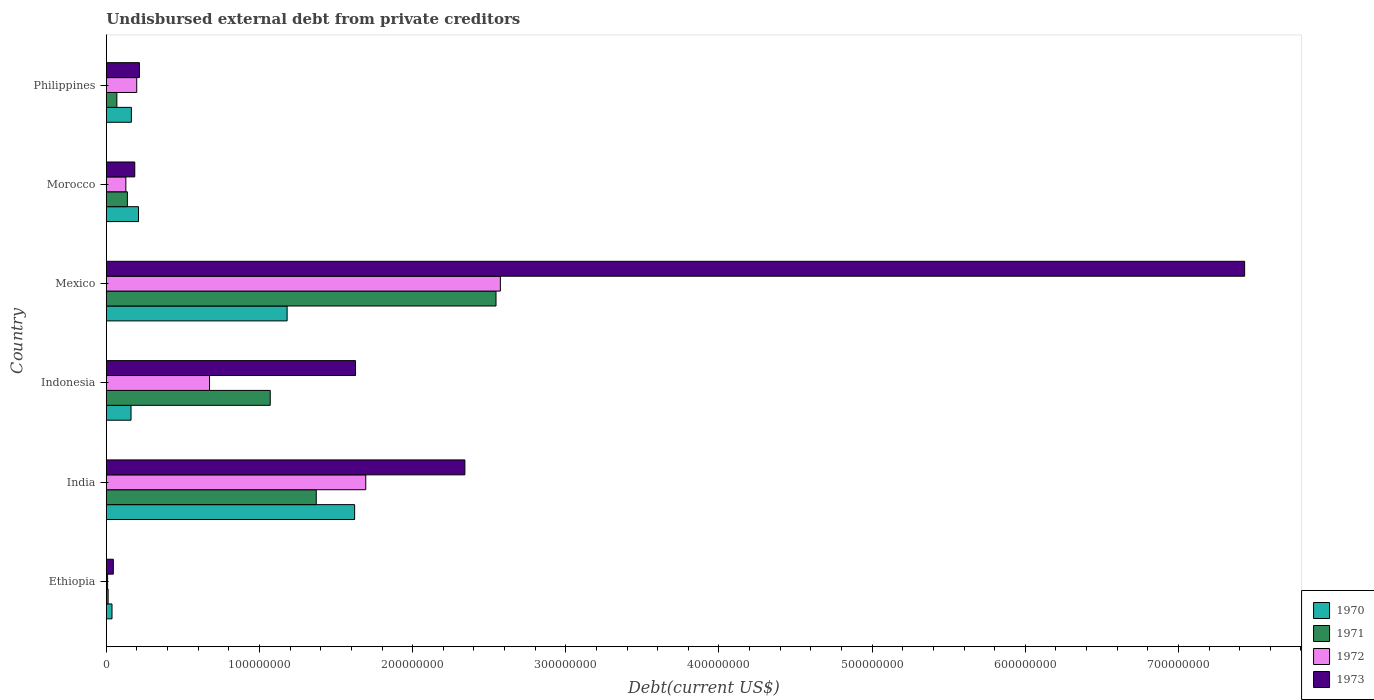How many groups of bars are there?
Your answer should be very brief. 6. Are the number of bars on each tick of the Y-axis equal?
Keep it short and to the point. Yes. How many bars are there on the 2nd tick from the top?
Your answer should be compact. 4. What is the label of the 3rd group of bars from the top?
Your response must be concise. Mexico. In how many cases, is the number of bars for a given country not equal to the number of legend labels?
Ensure brevity in your answer.  0. What is the total debt in 1972 in Morocco?
Your answer should be very brief. 1.27e+07. Across all countries, what is the maximum total debt in 1972?
Provide a short and direct response. 2.57e+08. Across all countries, what is the minimum total debt in 1970?
Give a very brief answer. 3.70e+06. In which country was the total debt in 1971 maximum?
Provide a succinct answer. Mexico. In which country was the total debt in 1971 minimum?
Keep it short and to the point. Ethiopia. What is the total total debt in 1972 in the graph?
Keep it short and to the point. 5.27e+08. What is the difference between the total debt in 1972 in Indonesia and that in Morocco?
Offer a very short reply. 5.46e+07. What is the difference between the total debt in 1970 in Morocco and the total debt in 1973 in Philippines?
Your answer should be very brief. -6.03e+05. What is the average total debt in 1970 per country?
Make the answer very short. 5.62e+07. What is the difference between the total debt in 1971 and total debt in 1972 in Philippines?
Make the answer very short. -1.30e+07. What is the ratio of the total debt in 1970 in Ethiopia to that in Philippines?
Ensure brevity in your answer.  0.23. Is the total debt in 1973 in India less than that in Morocco?
Provide a succinct answer. No. What is the difference between the highest and the second highest total debt in 1973?
Your response must be concise. 5.09e+08. What is the difference between the highest and the lowest total debt in 1971?
Give a very brief answer. 2.53e+08. Is the sum of the total debt in 1973 in Ethiopia and Morocco greater than the maximum total debt in 1971 across all countries?
Your answer should be compact. No. What does the 1st bar from the bottom in Morocco represents?
Offer a very short reply. 1970. What is the difference between two consecutive major ticks on the X-axis?
Provide a succinct answer. 1.00e+08. Are the values on the major ticks of X-axis written in scientific E-notation?
Offer a very short reply. No. Does the graph contain any zero values?
Offer a terse response. No. Does the graph contain grids?
Your answer should be compact. No. Where does the legend appear in the graph?
Offer a very short reply. Bottom right. How are the legend labels stacked?
Your response must be concise. Vertical. What is the title of the graph?
Your response must be concise. Undisbursed external debt from private creditors. Does "1982" appear as one of the legend labels in the graph?
Keep it short and to the point. No. What is the label or title of the X-axis?
Your answer should be compact. Debt(current US$). What is the label or title of the Y-axis?
Your answer should be compact. Country. What is the Debt(current US$) in 1970 in Ethiopia?
Your answer should be compact. 3.70e+06. What is the Debt(current US$) of 1971 in Ethiopia?
Ensure brevity in your answer.  1.16e+06. What is the Debt(current US$) of 1972 in Ethiopia?
Offer a very short reply. 8.20e+05. What is the Debt(current US$) in 1973 in Ethiopia?
Ensure brevity in your answer.  4.57e+06. What is the Debt(current US$) of 1970 in India?
Offer a very short reply. 1.62e+08. What is the Debt(current US$) of 1971 in India?
Offer a very short reply. 1.37e+08. What is the Debt(current US$) of 1972 in India?
Provide a succinct answer. 1.69e+08. What is the Debt(current US$) of 1973 in India?
Provide a succinct answer. 2.34e+08. What is the Debt(current US$) in 1970 in Indonesia?
Ensure brevity in your answer.  1.61e+07. What is the Debt(current US$) of 1971 in Indonesia?
Provide a succinct answer. 1.07e+08. What is the Debt(current US$) in 1972 in Indonesia?
Your answer should be very brief. 6.74e+07. What is the Debt(current US$) in 1973 in Indonesia?
Keep it short and to the point. 1.63e+08. What is the Debt(current US$) in 1970 in Mexico?
Your response must be concise. 1.18e+08. What is the Debt(current US$) of 1971 in Mexico?
Give a very brief answer. 2.54e+08. What is the Debt(current US$) in 1972 in Mexico?
Provide a succinct answer. 2.57e+08. What is the Debt(current US$) in 1973 in Mexico?
Provide a succinct answer. 7.43e+08. What is the Debt(current US$) in 1970 in Morocco?
Provide a short and direct response. 2.10e+07. What is the Debt(current US$) of 1971 in Morocco?
Your answer should be compact. 1.37e+07. What is the Debt(current US$) of 1972 in Morocco?
Offer a very short reply. 1.27e+07. What is the Debt(current US$) in 1973 in Morocco?
Make the answer very short. 1.86e+07. What is the Debt(current US$) of 1970 in Philippines?
Provide a succinct answer. 1.64e+07. What is the Debt(current US$) in 1971 in Philippines?
Keep it short and to the point. 6.87e+06. What is the Debt(current US$) of 1972 in Philippines?
Your answer should be compact. 1.99e+07. What is the Debt(current US$) in 1973 in Philippines?
Ensure brevity in your answer.  2.16e+07. Across all countries, what is the maximum Debt(current US$) in 1970?
Keep it short and to the point. 1.62e+08. Across all countries, what is the maximum Debt(current US$) of 1971?
Give a very brief answer. 2.54e+08. Across all countries, what is the maximum Debt(current US$) of 1972?
Ensure brevity in your answer.  2.57e+08. Across all countries, what is the maximum Debt(current US$) in 1973?
Offer a very short reply. 7.43e+08. Across all countries, what is the minimum Debt(current US$) of 1970?
Offer a very short reply. 3.70e+06. Across all countries, what is the minimum Debt(current US$) of 1971?
Give a very brief answer. 1.16e+06. Across all countries, what is the minimum Debt(current US$) in 1972?
Give a very brief answer. 8.20e+05. Across all countries, what is the minimum Debt(current US$) in 1973?
Provide a short and direct response. 4.57e+06. What is the total Debt(current US$) of 1970 in the graph?
Provide a succinct answer. 3.37e+08. What is the total Debt(current US$) of 1971 in the graph?
Your answer should be very brief. 5.20e+08. What is the total Debt(current US$) in 1972 in the graph?
Ensure brevity in your answer.  5.27e+08. What is the total Debt(current US$) in 1973 in the graph?
Your answer should be compact. 1.18e+09. What is the difference between the Debt(current US$) of 1970 in Ethiopia and that in India?
Offer a terse response. -1.58e+08. What is the difference between the Debt(current US$) of 1971 in Ethiopia and that in India?
Your answer should be very brief. -1.36e+08. What is the difference between the Debt(current US$) of 1972 in Ethiopia and that in India?
Make the answer very short. -1.69e+08. What is the difference between the Debt(current US$) of 1973 in Ethiopia and that in India?
Make the answer very short. -2.30e+08. What is the difference between the Debt(current US$) of 1970 in Ethiopia and that in Indonesia?
Keep it short and to the point. -1.24e+07. What is the difference between the Debt(current US$) of 1971 in Ethiopia and that in Indonesia?
Your answer should be very brief. -1.06e+08. What is the difference between the Debt(current US$) of 1972 in Ethiopia and that in Indonesia?
Provide a short and direct response. -6.66e+07. What is the difference between the Debt(current US$) of 1973 in Ethiopia and that in Indonesia?
Ensure brevity in your answer.  -1.58e+08. What is the difference between the Debt(current US$) of 1970 in Ethiopia and that in Mexico?
Your answer should be compact. -1.14e+08. What is the difference between the Debt(current US$) in 1971 in Ethiopia and that in Mexico?
Give a very brief answer. -2.53e+08. What is the difference between the Debt(current US$) in 1972 in Ethiopia and that in Mexico?
Make the answer very short. -2.56e+08. What is the difference between the Debt(current US$) in 1973 in Ethiopia and that in Mexico?
Provide a succinct answer. -7.39e+08. What is the difference between the Debt(current US$) in 1970 in Ethiopia and that in Morocco?
Offer a terse response. -1.73e+07. What is the difference between the Debt(current US$) in 1971 in Ethiopia and that in Morocco?
Keep it short and to the point. -1.26e+07. What is the difference between the Debt(current US$) of 1972 in Ethiopia and that in Morocco?
Offer a terse response. -1.19e+07. What is the difference between the Debt(current US$) of 1973 in Ethiopia and that in Morocco?
Give a very brief answer. -1.40e+07. What is the difference between the Debt(current US$) of 1970 in Ethiopia and that in Philippines?
Provide a short and direct response. -1.27e+07. What is the difference between the Debt(current US$) of 1971 in Ethiopia and that in Philippines?
Offer a very short reply. -5.71e+06. What is the difference between the Debt(current US$) in 1972 in Ethiopia and that in Philippines?
Make the answer very short. -1.90e+07. What is the difference between the Debt(current US$) in 1973 in Ethiopia and that in Philippines?
Offer a very short reply. -1.71e+07. What is the difference between the Debt(current US$) in 1970 in India and that in Indonesia?
Offer a very short reply. 1.46e+08. What is the difference between the Debt(current US$) in 1971 in India and that in Indonesia?
Offer a terse response. 3.00e+07. What is the difference between the Debt(current US$) in 1972 in India and that in Indonesia?
Make the answer very short. 1.02e+08. What is the difference between the Debt(current US$) in 1973 in India and that in Indonesia?
Keep it short and to the point. 7.14e+07. What is the difference between the Debt(current US$) in 1970 in India and that in Mexico?
Offer a terse response. 4.41e+07. What is the difference between the Debt(current US$) in 1971 in India and that in Mexico?
Keep it short and to the point. -1.17e+08. What is the difference between the Debt(current US$) of 1972 in India and that in Mexico?
Your answer should be very brief. -8.79e+07. What is the difference between the Debt(current US$) of 1973 in India and that in Mexico?
Offer a terse response. -5.09e+08. What is the difference between the Debt(current US$) of 1970 in India and that in Morocco?
Ensure brevity in your answer.  1.41e+08. What is the difference between the Debt(current US$) of 1971 in India and that in Morocco?
Make the answer very short. 1.23e+08. What is the difference between the Debt(current US$) of 1972 in India and that in Morocco?
Keep it short and to the point. 1.57e+08. What is the difference between the Debt(current US$) of 1973 in India and that in Morocco?
Your answer should be very brief. 2.16e+08. What is the difference between the Debt(current US$) in 1970 in India and that in Philippines?
Your answer should be very brief. 1.46e+08. What is the difference between the Debt(current US$) of 1971 in India and that in Philippines?
Your answer should be very brief. 1.30e+08. What is the difference between the Debt(current US$) of 1972 in India and that in Philippines?
Your answer should be compact. 1.50e+08. What is the difference between the Debt(current US$) of 1973 in India and that in Philippines?
Provide a short and direct response. 2.12e+08. What is the difference between the Debt(current US$) in 1970 in Indonesia and that in Mexico?
Offer a very short reply. -1.02e+08. What is the difference between the Debt(current US$) in 1971 in Indonesia and that in Mexico?
Your response must be concise. -1.47e+08. What is the difference between the Debt(current US$) in 1972 in Indonesia and that in Mexico?
Give a very brief answer. -1.90e+08. What is the difference between the Debt(current US$) of 1973 in Indonesia and that in Mexico?
Provide a succinct answer. -5.81e+08. What is the difference between the Debt(current US$) of 1970 in Indonesia and that in Morocco?
Your answer should be compact. -4.89e+06. What is the difference between the Debt(current US$) in 1971 in Indonesia and that in Morocco?
Your response must be concise. 9.33e+07. What is the difference between the Debt(current US$) in 1972 in Indonesia and that in Morocco?
Provide a short and direct response. 5.46e+07. What is the difference between the Debt(current US$) in 1973 in Indonesia and that in Morocco?
Offer a very short reply. 1.44e+08. What is the difference between the Debt(current US$) of 1970 in Indonesia and that in Philippines?
Your answer should be very brief. -2.28e+05. What is the difference between the Debt(current US$) in 1971 in Indonesia and that in Philippines?
Ensure brevity in your answer.  1.00e+08. What is the difference between the Debt(current US$) of 1972 in Indonesia and that in Philippines?
Offer a terse response. 4.75e+07. What is the difference between the Debt(current US$) in 1973 in Indonesia and that in Philippines?
Keep it short and to the point. 1.41e+08. What is the difference between the Debt(current US$) of 1970 in Mexico and that in Morocco?
Give a very brief answer. 9.70e+07. What is the difference between the Debt(current US$) in 1971 in Mexico and that in Morocco?
Keep it short and to the point. 2.41e+08. What is the difference between the Debt(current US$) of 1972 in Mexico and that in Morocco?
Make the answer very short. 2.45e+08. What is the difference between the Debt(current US$) of 1973 in Mexico and that in Morocco?
Offer a very short reply. 7.25e+08. What is the difference between the Debt(current US$) of 1970 in Mexico and that in Philippines?
Make the answer very short. 1.02e+08. What is the difference between the Debt(current US$) in 1971 in Mexico and that in Philippines?
Ensure brevity in your answer.  2.48e+08. What is the difference between the Debt(current US$) of 1972 in Mexico and that in Philippines?
Your response must be concise. 2.37e+08. What is the difference between the Debt(current US$) in 1973 in Mexico and that in Philippines?
Your answer should be very brief. 7.22e+08. What is the difference between the Debt(current US$) of 1970 in Morocco and that in Philippines?
Ensure brevity in your answer.  4.66e+06. What is the difference between the Debt(current US$) of 1971 in Morocco and that in Philippines?
Your answer should be very brief. 6.88e+06. What is the difference between the Debt(current US$) of 1972 in Morocco and that in Philippines?
Provide a short and direct response. -7.12e+06. What is the difference between the Debt(current US$) of 1973 in Morocco and that in Philippines?
Give a very brief answer. -3.06e+06. What is the difference between the Debt(current US$) of 1970 in Ethiopia and the Debt(current US$) of 1971 in India?
Your answer should be very brief. -1.33e+08. What is the difference between the Debt(current US$) in 1970 in Ethiopia and the Debt(current US$) in 1972 in India?
Your answer should be very brief. -1.66e+08. What is the difference between the Debt(current US$) in 1970 in Ethiopia and the Debt(current US$) in 1973 in India?
Make the answer very short. -2.30e+08. What is the difference between the Debt(current US$) of 1971 in Ethiopia and the Debt(current US$) of 1972 in India?
Your answer should be compact. -1.68e+08. What is the difference between the Debt(current US$) of 1971 in Ethiopia and the Debt(current US$) of 1973 in India?
Give a very brief answer. -2.33e+08. What is the difference between the Debt(current US$) in 1972 in Ethiopia and the Debt(current US$) in 1973 in India?
Ensure brevity in your answer.  -2.33e+08. What is the difference between the Debt(current US$) in 1970 in Ethiopia and the Debt(current US$) in 1971 in Indonesia?
Ensure brevity in your answer.  -1.03e+08. What is the difference between the Debt(current US$) of 1970 in Ethiopia and the Debt(current US$) of 1972 in Indonesia?
Your response must be concise. -6.37e+07. What is the difference between the Debt(current US$) in 1970 in Ethiopia and the Debt(current US$) in 1973 in Indonesia?
Offer a very short reply. -1.59e+08. What is the difference between the Debt(current US$) in 1971 in Ethiopia and the Debt(current US$) in 1972 in Indonesia?
Your answer should be compact. -6.62e+07. What is the difference between the Debt(current US$) of 1971 in Ethiopia and the Debt(current US$) of 1973 in Indonesia?
Ensure brevity in your answer.  -1.62e+08. What is the difference between the Debt(current US$) in 1972 in Ethiopia and the Debt(current US$) in 1973 in Indonesia?
Make the answer very short. -1.62e+08. What is the difference between the Debt(current US$) of 1970 in Ethiopia and the Debt(current US$) of 1971 in Mexico?
Provide a succinct answer. -2.51e+08. What is the difference between the Debt(current US$) in 1970 in Ethiopia and the Debt(current US$) in 1972 in Mexico?
Provide a short and direct response. -2.54e+08. What is the difference between the Debt(current US$) in 1970 in Ethiopia and the Debt(current US$) in 1973 in Mexico?
Your response must be concise. -7.40e+08. What is the difference between the Debt(current US$) in 1971 in Ethiopia and the Debt(current US$) in 1972 in Mexico?
Keep it short and to the point. -2.56e+08. What is the difference between the Debt(current US$) in 1971 in Ethiopia and the Debt(current US$) in 1973 in Mexico?
Offer a terse response. -7.42e+08. What is the difference between the Debt(current US$) in 1972 in Ethiopia and the Debt(current US$) in 1973 in Mexico?
Offer a terse response. -7.42e+08. What is the difference between the Debt(current US$) in 1970 in Ethiopia and the Debt(current US$) in 1971 in Morocco?
Ensure brevity in your answer.  -1.01e+07. What is the difference between the Debt(current US$) of 1970 in Ethiopia and the Debt(current US$) of 1972 in Morocco?
Offer a very short reply. -9.04e+06. What is the difference between the Debt(current US$) in 1970 in Ethiopia and the Debt(current US$) in 1973 in Morocco?
Provide a short and direct response. -1.49e+07. What is the difference between the Debt(current US$) in 1971 in Ethiopia and the Debt(current US$) in 1972 in Morocco?
Your answer should be compact. -1.16e+07. What is the difference between the Debt(current US$) in 1971 in Ethiopia and the Debt(current US$) in 1973 in Morocco?
Offer a very short reply. -1.74e+07. What is the difference between the Debt(current US$) of 1972 in Ethiopia and the Debt(current US$) of 1973 in Morocco?
Provide a succinct answer. -1.77e+07. What is the difference between the Debt(current US$) of 1970 in Ethiopia and the Debt(current US$) of 1971 in Philippines?
Your answer should be very brief. -3.18e+06. What is the difference between the Debt(current US$) in 1970 in Ethiopia and the Debt(current US$) in 1972 in Philippines?
Give a very brief answer. -1.62e+07. What is the difference between the Debt(current US$) of 1970 in Ethiopia and the Debt(current US$) of 1973 in Philippines?
Keep it short and to the point. -1.79e+07. What is the difference between the Debt(current US$) in 1971 in Ethiopia and the Debt(current US$) in 1972 in Philippines?
Your answer should be very brief. -1.87e+07. What is the difference between the Debt(current US$) in 1971 in Ethiopia and the Debt(current US$) in 1973 in Philippines?
Make the answer very short. -2.05e+07. What is the difference between the Debt(current US$) of 1972 in Ethiopia and the Debt(current US$) of 1973 in Philippines?
Keep it short and to the point. -2.08e+07. What is the difference between the Debt(current US$) of 1970 in India and the Debt(current US$) of 1971 in Indonesia?
Give a very brief answer. 5.51e+07. What is the difference between the Debt(current US$) of 1970 in India and the Debt(current US$) of 1972 in Indonesia?
Ensure brevity in your answer.  9.47e+07. What is the difference between the Debt(current US$) of 1970 in India and the Debt(current US$) of 1973 in Indonesia?
Offer a terse response. -5.84e+05. What is the difference between the Debt(current US$) in 1971 in India and the Debt(current US$) in 1972 in Indonesia?
Your response must be concise. 6.97e+07. What is the difference between the Debt(current US$) of 1971 in India and the Debt(current US$) of 1973 in Indonesia?
Offer a terse response. -2.56e+07. What is the difference between the Debt(current US$) of 1972 in India and the Debt(current US$) of 1973 in Indonesia?
Offer a terse response. 6.68e+06. What is the difference between the Debt(current US$) in 1970 in India and the Debt(current US$) in 1971 in Mexico?
Provide a short and direct response. -9.23e+07. What is the difference between the Debt(current US$) in 1970 in India and the Debt(current US$) in 1972 in Mexico?
Your response must be concise. -9.51e+07. What is the difference between the Debt(current US$) of 1970 in India and the Debt(current US$) of 1973 in Mexico?
Give a very brief answer. -5.81e+08. What is the difference between the Debt(current US$) in 1971 in India and the Debt(current US$) in 1972 in Mexico?
Offer a very short reply. -1.20e+08. What is the difference between the Debt(current US$) of 1971 in India and the Debt(current US$) of 1973 in Mexico?
Keep it short and to the point. -6.06e+08. What is the difference between the Debt(current US$) in 1972 in India and the Debt(current US$) in 1973 in Mexico?
Provide a succinct answer. -5.74e+08. What is the difference between the Debt(current US$) of 1970 in India and the Debt(current US$) of 1971 in Morocco?
Offer a terse response. 1.48e+08. What is the difference between the Debt(current US$) of 1970 in India and the Debt(current US$) of 1972 in Morocco?
Offer a very short reply. 1.49e+08. What is the difference between the Debt(current US$) of 1970 in India and the Debt(current US$) of 1973 in Morocco?
Your response must be concise. 1.44e+08. What is the difference between the Debt(current US$) of 1971 in India and the Debt(current US$) of 1972 in Morocco?
Offer a terse response. 1.24e+08. What is the difference between the Debt(current US$) in 1971 in India and the Debt(current US$) in 1973 in Morocco?
Offer a very short reply. 1.19e+08. What is the difference between the Debt(current US$) of 1972 in India and the Debt(current US$) of 1973 in Morocco?
Provide a succinct answer. 1.51e+08. What is the difference between the Debt(current US$) in 1970 in India and the Debt(current US$) in 1971 in Philippines?
Offer a terse response. 1.55e+08. What is the difference between the Debt(current US$) in 1970 in India and the Debt(current US$) in 1972 in Philippines?
Offer a terse response. 1.42e+08. What is the difference between the Debt(current US$) of 1970 in India and the Debt(current US$) of 1973 in Philippines?
Offer a very short reply. 1.41e+08. What is the difference between the Debt(current US$) of 1971 in India and the Debt(current US$) of 1972 in Philippines?
Your answer should be compact. 1.17e+08. What is the difference between the Debt(current US$) in 1971 in India and the Debt(current US$) in 1973 in Philippines?
Provide a short and direct response. 1.15e+08. What is the difference between the Debt(current US$) of 1972 in India and the Debt(current US$) of 1973 in Philippines?
Your response must be concise. 1.48e+08. What is the difference between the Debt(current US$) of 1970 in Indonesia and the Debt(current US$) of 1971 in Mexico?
Your response must be concise. -2.38e+08. What is the difference between the Debt(current US$) of 1970 in Indonesia and the Debt(current US$) of 1972 in Mexico?
Provide a short and direct response. -2.41e+08. What is the difference between the Debt(current US$) in 1970 in Indonesia and the Debt(current US$) in 1973 in Mexico?
Give a very brief answer. -7.27e+08. What is the difference between the Debt(current US$) of 1971 in Indonesia and the Debt(current US$) of 1972 in Mexico?
Offer a terse response. -1.50e+08. What is the difference between the Debt(current US$) of 1971 in Indonesia and the Debt(current US$) of 1973 in Mexico?
Make the answer very short. -6.36e+08. What is the difference between the Debt(current US$) of 1972 in Indonesia and the Debt(current US$) of 1973 in Mexico?
Your answer should be very brief. -6.76e+08. What is the difference between the Debt(current US$) of 1970 in Indonesia and the Debt(current US$) of 1971 in Morocco?
Give a very brief answer. 2.38e+06. What is the difference between the Debt(current US$) in 1970 in Indonesia and the Debt(current US$) in 1972 in Morocco?
Provide a succinct answer. 3.39e+06. What is the difference between the Debt(current US$) in 1970 in Indonesia and the Debt(current US$) in 1973 in Morocco?
Offer a very short reply. -2.44e+06. What is the difference between the Debt(current US$) of 1971 in Indonesia and the Debt(current US$) of 1972 in Morocco?
Offer a terse response. 9.43e+07. What is the difference between the Debt(current US$) of 1971 in Indonesia and the Debt(current US$) of 1973 in Morocco?
Offer a terse response. 8.85e+07. What is the difference between the Debt(current US$) in 1972 in Indonesia and the Debt(current US$) in 1973 in Morocco?
Make the answer very short. 4.88e+07. What is the difference between the Debt(current US$) of 1970 in Indonesia and the Debt(current US$) of 1971 in Philippines?
Ensure brevity in your answer.  9.25e+06. What is the difference between the Debt(current US$) in 1970 in Indonesia and the Debt(current US$) in 1972 in Philippines?
Provide a short and direct response. -3.73e+06. What is the difference between the Debt(current US$) in 1970 in Indonesia and the Debt(current US$) in 1973 in Philippines?
Provide a short and direct response. -5.49e+06. What is the difference between the Debt(current US$) in 1971 in Indonesia and the Debt(current US$) in 1972 in Philippines?
Your answer should be compact. 8.72e+07. What is the difference between the Debt(current US$) of 1971 in Indonesia and the Debt(current US$) of 1973 in Philippines?
Your response must be concise. 8.54e+07. What is the difference between the Debt(current US$) in 1972 in Indonesia and the Debt(current US$) in 1973 in Philippines?
Offer a terse response. 4.58e+07. What is the difference between the Debt(current US$) of 1970 in Mexico and the Debt(current US$) of 1971 in Morocco?
Offer a terse response. 1.04e+08. What is the difference between the Debt(current US$) of 1970 in Mexico and the Debt(current US$) of 1972 in Morocco?
Keep it short and to the point. 1.05e+08. What is the difference between the Debt(current US$) of 1970 in Mexico and the Debt(current US$) of 1973 in Morocco?
Provide a short and direct response. 9.95e+07. What is the difference between the Debt(current US$) in 1971 in Mexico and the Debt(current US$) in 1972 in Morocco?
Offer a very short reply. 2.42e+08. What is the difference between the Debt(current US$) in 1971 in Mexico and the Debt(current US$) in 1973 in Morocco?
Ensure brevity in your answer.  2.36e+08. What is the difference between the Debt(current US$) of 1972 in Mexico and the Debt(current US$) of 1973 in Morocco?
Make the answer very short. 2.39e+08. What is the difference between the Debt(current US$) in 1970 in Mexico and the Debt(current US$) in 1971 in Philippines?
Your answer should be very brief. 1.11e+08. What is the difference between the Debt(current US$) of 1970 in Mexico and the Debt(current US$) of 1972 in Philippines?
Your answer should be compact. 9.82e+07. What is the difference between the Debt(current US$) in 1970 in Mexico and the Debt(current US$) in 1973 in Philippines?
Ensure brevity in your answer.  9.64e+07. What is the difference between the Debt(current US$) in 1971 in Mexico and the Debt(current US$) in 1972 in Philippines?
Your answer should be compact. 2.35e+08. What is the difference between the Debt(current US$) in 1971 in Mexico and the Debt(current US$) in 1973 in Philippines?
Keep it short and to the point. 2.33e+08. What is the difference between the Debt(current US$) of 1972 in Mexico and the Debt(current US$) of 1973 in Philippines?
Offer a very short reply. 2.36e+08. What is the difference between the Debt(current US$) of 1970 in Morocco and the Debt(current US$) of 1971 in Philippines?
Your answer should be very brief. 1.41e+07. What is the difference between the Debt(current US$) of 1970 in Morocco and the Debt(current US$) of 1972 in Philippines?
Ensure brevity in your answer.  1.16e+06. What is the difference between the Debt(current US$) in 1970 in Morocco and the Debt(current US$) in 1973 in Philippines?
Offer a terse response. -6.03e+05. What is the difference between the Debt(current US$) in 1971 in Morocco and the Debt(current US$) in 1972 in Philippines?
Make the answer very short. -6.10e+06. What is the difference between the Debt(current US$) in 1971 in Morocco and the Debt(current US$) in 1973 in Philippines?
Provide a succinct answer. -7.87e+06. What is the difference between the Debt(current US$) in 1972 in Morocco and the Debt(current US$) in 1973 in Philippines?
Offer a terse response. -8.88e+06. What is the average Debt(current US$) of 1970 per country?
Provide a succinct answer. 5.62e+07. What is the average Debt(current US$) in 1971 per country?
Give a very brief answer. 8.67e+07. What is the average Debt(current US$) of 1972 per country?
Provide a short and direct response. 8.79e+07. What is the average Debt(current US$) in 1973 per country?
Make the answer very short. 1.97e+08. What is the difference between the Debt(current US$) of 1970 and Debt(current US$) of 1971 in Ethiopia?
Provide a succinct answer. 2.53e+06. What is the difference between the Debt(current US$) in 1970 and Debt(current US$) in 1972 in Ethiopia?
Give a very brief answer. 2.88e+06. What is the difference between the Debt(current US$) of 1970 and Debt(current US$) of 1973 in Ethiopia?
Provide a short and direct response. -8.70e+05. What is the difference between the Debt(current US$) of 1971 and Debt(current US$) of 1972 in Ethiopia?
Your answer should be compact. 3.45e+05. What is the difference between the Debt(current US$) of 1971 and Debt(current US$) of 1973 in Ethiopia?
Give a very brief answer. -3.40e+06. What is the difference between the Debt(current US$) in 1972 and Debt(current US$) in 1973 in Ethiopia?
Keep it short and to the point. -3.75e+06. What is the difference between the Debt(current US$) of 1970 and Debt(current US$) of 1971 in India?
Provide a short and direct response. 2.51e+07. What is the difference between the Debt(current US$) in 1970 and Debt(current US$) in 1972 in India?
Keep it short and to the point. -7.26e+06. What is the difference between the Debt(current US$) in 1970 and Debt(current US$) in 1973 in India?
Make the answer very short. -7.20e+07. What is the difference between the Debt(current US$) in 1971 and Debt(current US$) in 1972 in India?
Your response must be concise. -3.23e+07. What is the difference between the Debt(current US$) of 1971 and Debt(current US$) of 1973 in India?
Give a very brief answer. -9.70e+07. What is the difference between the Debt(current US$) of 1972 and Debt(current US$) of 1973 in India?
Ensure brevity in your answer.  -6.47e+07. What is the difference between the Debt(current US$) of 1970 and Debt(current US$) of 1971 in Indonesia?
Give a very brief answer. -9.09e+07. What is the difference between the Debt(current US$) in 1970 and Debt(current US$) in 1972 in Indonesia?
Your answer should be very brief. -5.12e+07. What is the difference between the Debt(current US$) of 1970 and Debt(current US$) of 1973 in Indonesia?
Your answer should be compact. -1.47e+08. What is the difference between the Debt(current US$) in 1971 and Debt(current US$) in 1972 in Indonesia?
Provide a succinct answer. 3.96e+07. What is the difference between the Debt(current US$) in 1971 and Debt(current US$) in 1973 in Indonesia?
Make the answer very short. -5.57e+07. What is the difference between the Debt(current US$) in 1972 and Debt(current US$) in 1973 in Indonesia?
Ensure brevity in your answer.  -9.53e+07. What is the difference between the Debt(current US$) in 1970 and Debt(current US$) in 1971 in Mexico?
Offer a very short reply. -1.36e+08. What is the difference between the Debt(current US$) in 1970 and Debt(current US$) in 1972 in Mexico?
Give a very brief answer. -1.39e+08. What is the difference between the Debt(current US$) in 1970 and Debt(current US$) in 1973 in Mexico?
Your answer should be very brief. -6.25e+08. What is the difference between the Debt(current US$) in 1971 and Debt(current US$) in 1972 in Mexico?
Ensure brevity in your answer.  -2.84e+06. What is the difference between the Debt(current US$) of 1971 and Debt(current US$) of 1973 in Mexico?
Provide a succinct answer. -4.89e+08. What is the difference between the Debt(current US$) of 1972 and Debt(current US$) of 1973 in Mexico?
Your response must be concise. -4.86e+08. What is the difference between the Debt(current US$) in 1970 and Debt(current US$) in 1971 in Morocco?
Ensure brevity in your answer.  7.27e+06. What is the difference between the Debt(current US$) in 1970 and Debt(current US$) in 1972 in Morocco?
Ensure brevity in your answer.  8.28e+06. What is the difference between the Debt(current US$) of 1970 and Debt(current US$) of 1973 in Morocco?
Offer a terse response. 2.45e+06. What is the difference between the Debt(current US$) of 1971 and Debt(current US$) of 1972 in Morocco?
Provide a short and direct response. 1.01e+06. What is the difference between the Debt(current US$) in 1971 and Debt(current US$) in 1973 in Morocco?
Make the answer very short. -4.81e+06. What is the difference between the Debt(current US$) in 1972 and Debt(current US$) in 1973 in Morocco?
Offer a very short reply. -5.82e+06. What is the difference between the Debt(current US$) of 1970 and Debt(current US$) of 1971 in Philippines?
Offer a terse response. 9.48e+06. What is the difference between the Debt(current US$) in 1970 and Debt(current US$) in 1972 in Philippines?
Your answer should be compact. -3.50e+06. What is the difference between the Debt(current US$) in 1970 and Debt(current US$) in 1973 in Philippines?
Provide a succinct answer. -5.27e+06. What is the difference between the Debt(current US$) in 1971 and Debt(current US$) in 1972 in Philippines?
Ensure brevity in your answer.  -1.30e+07. What is the difference between the Debt(current US$) of 1971 and Debt(current US$) of 1973 in Philippines?
Your response must be concise. -1.47e+07. What is the difference between the Debt(current US$) in 1972 and Debt(current US$) in 1973 in Philippines?
Your response must be concise. -1.76e+06. What is the ratio of the Debt(current US$) in 1970 in Ethiopia to that in India?
Ensure brevity in your answer.  0.02. What is the ratio of the Debt(current US$) in 1971 in Ethiopia to that in India?
Make the answer very short. 0.01. What is the ratio of the Debt(current US$) of 1972 in Ethiopia to that in India?
Offer a terse response. 0. What is the ratio of the Debt(current US$) in 1973 in Ethiopia to that in India?
Your response must be concise. 0.02. What is the ratio of the Debt(current US$) in 1970 in Ethiopia to that in Indonesia?
Your answer should be very brief. 0.23. What is the ratio of the Debt(current US$) in 1971 in Ethiopia to that in Indonesia?
Make the answer very short. 0.01. What is the ratio of the Debt(current US$) in 1972 in Ethiopia to that in Indonesia?
Make the answer very short. 0.01. What is the ratio of the Debt(current US$) in 1973 in Ethiopia to that in Indonesia?
Offer a terse response. 0.03. What is the ratio of the Debt(current US$) in 1970 in Ethiopia to that in Mexico?
Offer a terse response. 0.03. What is the ratio of the Debt(current US$) of 1971 in Ethiopia to that in Mexico?
Your answer should be very brief. 0. What is the ratio of the Debt(current US$) of 1972 in Ethiopia to that in Mexico?
Provide a succinct answer. 0. What is the ratio of the Debt(current US$) in 1973 in Ethiopia to that in Mexico?
Make the answer very short. 0.01. What is the ratio of the Debt(current US$) in 1970 in Ethiopia to that in Morocco?
Offer a terse response. 0.18. What is the ratio of the Debt(current US$) in 1971 in Ethiopia to that in Morocco?
Make the answer very short. 0.08. What is the ratio of the Debt(current US$) of 1972 in Ethiopia to that in Morocco?
Your response must be concise. 0.06. What is the ratio of the Debt(current US$) of 1973 in Ethiopia to that in Morocco?
Your answer should be compact. 0.25. What is the ratio of the Debt(current US$) of 1970 in Ethiopia to that in Philippines?
Provide a short and direct response. 0.23. What is the ratio of the Debt(current US$) of 1971 in Ethiopia to that in Philippines?
Your response must be concise. 0.17. What is the ratio of the Debt(current US$) of 1972 in Ethiopia to that in Philippines?
Offer a very short reply. 0.04. What is the ratio of the Debt(current US$) of 1973 in Ethiopia to that in Philippines?
Your response must be concise. 0.21. What is the ratio of the Debt(current US$) of 1970 in India to that in Indonesia?
Make the answer very short. 10.05. What is the ratio of the Debt(current US$) in 1971 in India to that in Indonesia?
Provide a succinct answer. 1.28. What is the ratio of the Debt(current US$) of 1972 in India to that in Indonesia?
Keep it short and to the point. 2.51. What is the ratio of the Debt(current US$) of 1973 in India to that in Indonesia?
Keep it short and to the point. 1.44. What is the ratio of the Debt(current US$) of 1970 in India to that in Mexico?
Keep it short and to the point. 1.37. What is the ratio of the Debt(current US$) in 1971 in India to that in Mexico?
Ensure brevity in your answer.  0.54. What is the ratio of the Debt(current US$) of 1972 in India to that in Mexico?
Your response must be concise. 0.66. What is the ratio of the Debt(current US$) in 1973 in India to that in Mexico?
Make the answer very short. 0.32. What is the ratio of the Debt(current US$) in 1970 in India to that in Morocco?
Keep it short and to the point. 7.71. What is the ratio of the Debt(current US$) in 1971 in India to that in Morocco?
Your answer should be very brief. 9.97. What is the ratio of the Debt(current US$) of 1972 in India to that in Morocco?
Your answer should be compact. 13.3. What is the ratio of the Debt(current US$) in 1973 in India to that in Morocco?
Offer a very short reply. 12.61. What is the ratio of the Debt(current US$) in 1970 in India to that in Philippines?
Keep it short and to the point. 9.91. What is the ratio of the Debt(current US$) of 1971 in India to that in Philippines?
Your answer should be very brief. 19.95. What is the ratio of the Debt(current US$) of 1972 in India to that in Philippines?
Ensure brevity in your answer.  8.53. What is the ratio of the Debt(current US$) of 1973 in India to that in Philippines?
Give a very brief answer. 10.83. What is the ratio of the Debt(current US$) of 1970 in Indonesia to that in Mexico?
Offer a terse response. 0.14. What is the ratio of the Debt(current US$) in 1971 in Indonesia to that in Mexico?
Your answer should be compact. 0.42. What is the ratio of the Debt(current US$) in 1972 in Indonesia to that in Mexico?
Give a very brief answer. 0.26. What is the ratio of the Debt(current US$) of 1973 in Indonesia to that in Mexico?
Provide a short and direct response. 0.22. What is the ratio of the Debt(current US$) in 1970 in Indonesia to that in Morocco?
Keep it short and to the point. 0.77. What is the ratio of the Debt(current US$) in 1971 in Indonesia to that in Morocco?
Ensure brevity in your answer.  7.78. What is the ratio of the Debt(current US$) in 1972 in Indonesia to that in Morocco?
Your response must be concise. 5.29. What is the ratio of the Debt(current US$) in 1973 in Indonesia to that in Morocco?
Provide a short and direct response. 8.77. What is the ratio of the Debt(current US$) in 1970 in Indonesia to that in Philippines?
Provide a short and direct response. 0.99. What is the ratio of the Debt(current US$) in 1971 in Indonesia to that in Philippines?
Make the answer very short. 15.57. What is the ratio of the Debt(current US$) of 1972 in Indonesia to that in Philippines?
Provide a succinct answer. 3.39. What is the ratio of the Debt(current US$) of 1973 in Indonesia to that in Philippines?
Give a very brief answer. 7.53. What is the ratio of the Debt(current US$) of 1970 in Mexico to that in Morocco?
Provide a short and direct response. 5.62. What is the ratio of the Debt(current US$) in 1971 in Mexico to that in Morocco?
Your answer should be compact. 18.51. What is the ratio of the Debt(current US$) in 1972 in Mexico to that in Morocco?
Ensure brevity in your answer.  20.2. What is the ratio of the Debt(current US$) of 1973 in Mexico to that in Morocco?
Offer a very short reply. 40.04. What is the ratio of the Debt(current US$) in 1970 in Mexico to that in Philippines?
Provide a succinct answer. 7.22. What is the ratio of the Debt(current US$) in 1971 in Mexico to that in Philippines?
Make the answer very short. 37.02. What is the ratio of the Debt(current US$) in 1972 in Mexico to that in Philippines?
Provide a short and direct response. 12.96. What is the ratio of the Debt(current US$) of 1973 in Mexico to that in Philippines?
Provide a short and direct response. 34.38. What is the ratio of the Debt(current US$) in 1970 in Morocco to that in Philippines?
Give a very brief answer. 1.29. What is the ratio of the Debt(current US$) of 1971 in Morocco to that in Philippines?
Ensure brevity in your answer.  2. What is the ratio of the Debt(current US$) in 1972 in Morocco to that in Philippines?
Keep it short and to the point. 0.64. What is the ratio of the Debt(current US$) of 1973 in Morocco to that in Philippines?
Provide a succinct answer. 0.86. What is the difference between the highest and the second highest Debt(current US$) of 1970?
Make the answer very short. 4.41e+07. What is the difference between the highest and the second highest Debt(current US$) of 1971?
Provide a short and direct response. 1.17e+08. What is the difference between the highest and the second highest Debt(current US$) in 1972?
Provide a succinct answer. 8.79e+07. What is the difference between the highest and the second highest Debt(current US$) of 1973?
Provide a short and direct response. 5.09e+08. What is the difference between the highest and the lowest Debt(current US$) in 1970?
Your answer should be compact. 1.58e+08. What is the difference between the highest and the lowest Debt(current US$) of 1971?
Your answer should be very brief. 2.53e+08. What is the difference between the highest and the lowest Debt(current US$) of 1972?
Keep it short and to the point. 2.56e+08. What is the difference between the highest and the lowest Debt(current US$) in 1973?
Your answer should be compact. 7.39e+08. 